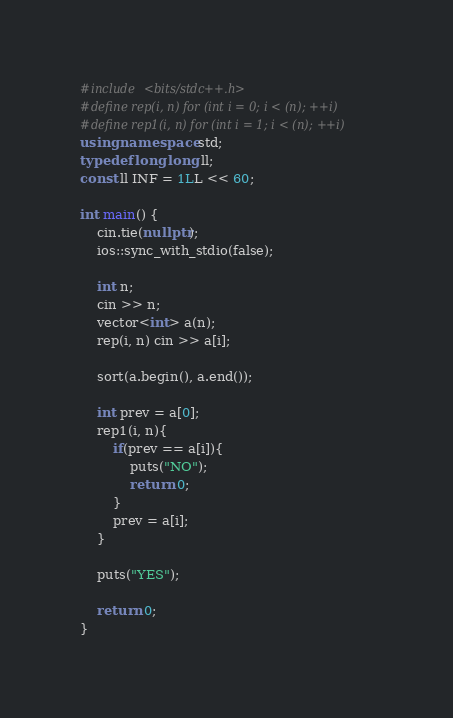Convert code to text. <code><loc_0><loc_0><loc_500><loc_500><_C++_>#include <bits/stdc++.h>
#define rep(i, n) for (int i = 0; i < (n); ++i)
#define rep1(i, n) for (int i = 1; i < (n); ++i)
using namespace std;
typedef long long ll;
const ll INF = 1LL << 60;

int main() {
    cin.tie(nullptr);
    ios::sync_with_stdio(false);

    int n;
    cin >> n;
    vector<int> a(n);
    rep(i, n) cin >> a[i];

    sort(a.begin(), a.end());

    int prev = a[0];
    rep1(i, n){
        if(prev == a[i]){
            puts("NO");
            return 0;
        }
        prev = a[i];
    }

    puts("YES");

    return 0;
}</code> 